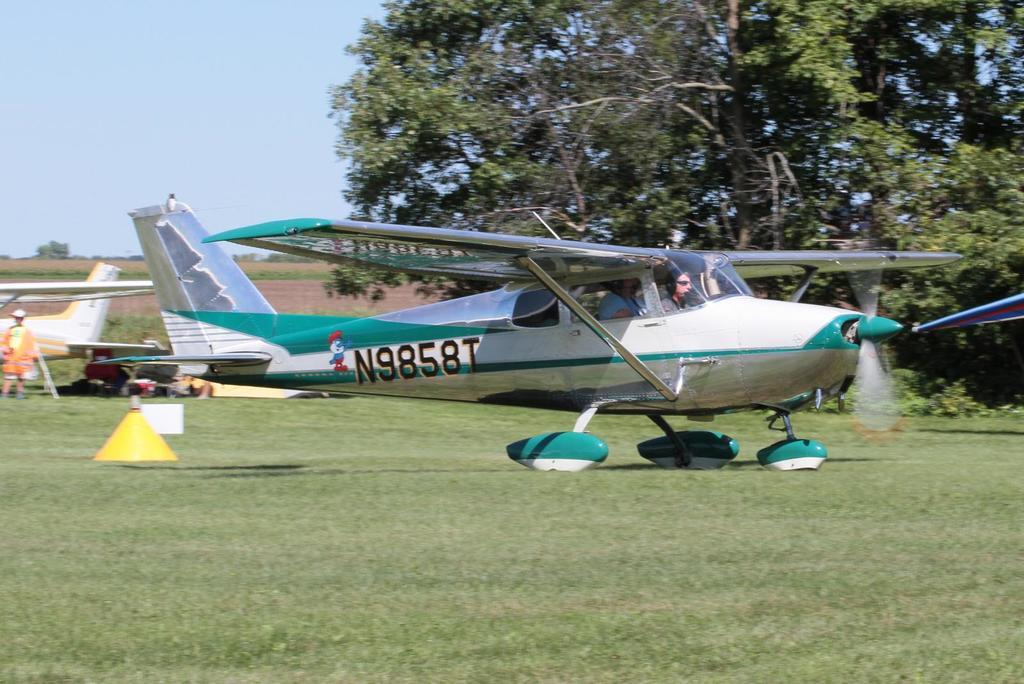<image>
Provide a brief description of the given image. A plane is parked in the grass with a smurf followed by N9858T on the side. 